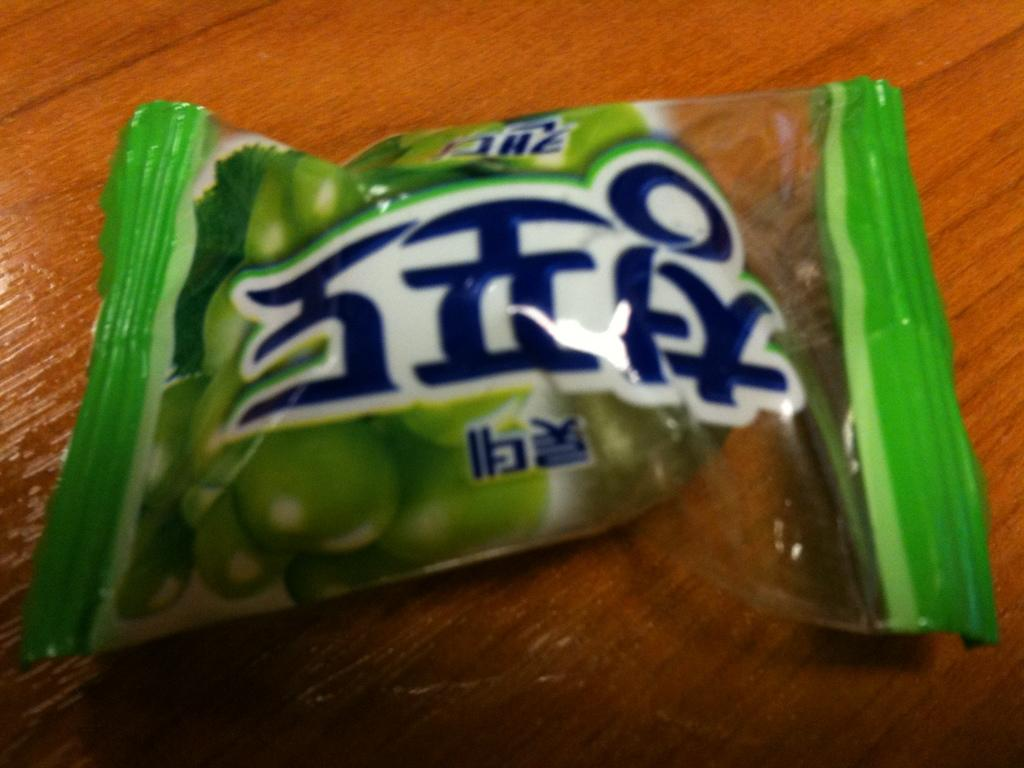<image>
Summarize the visual content of the image. A small package of vegetables has Asian writing on it. 